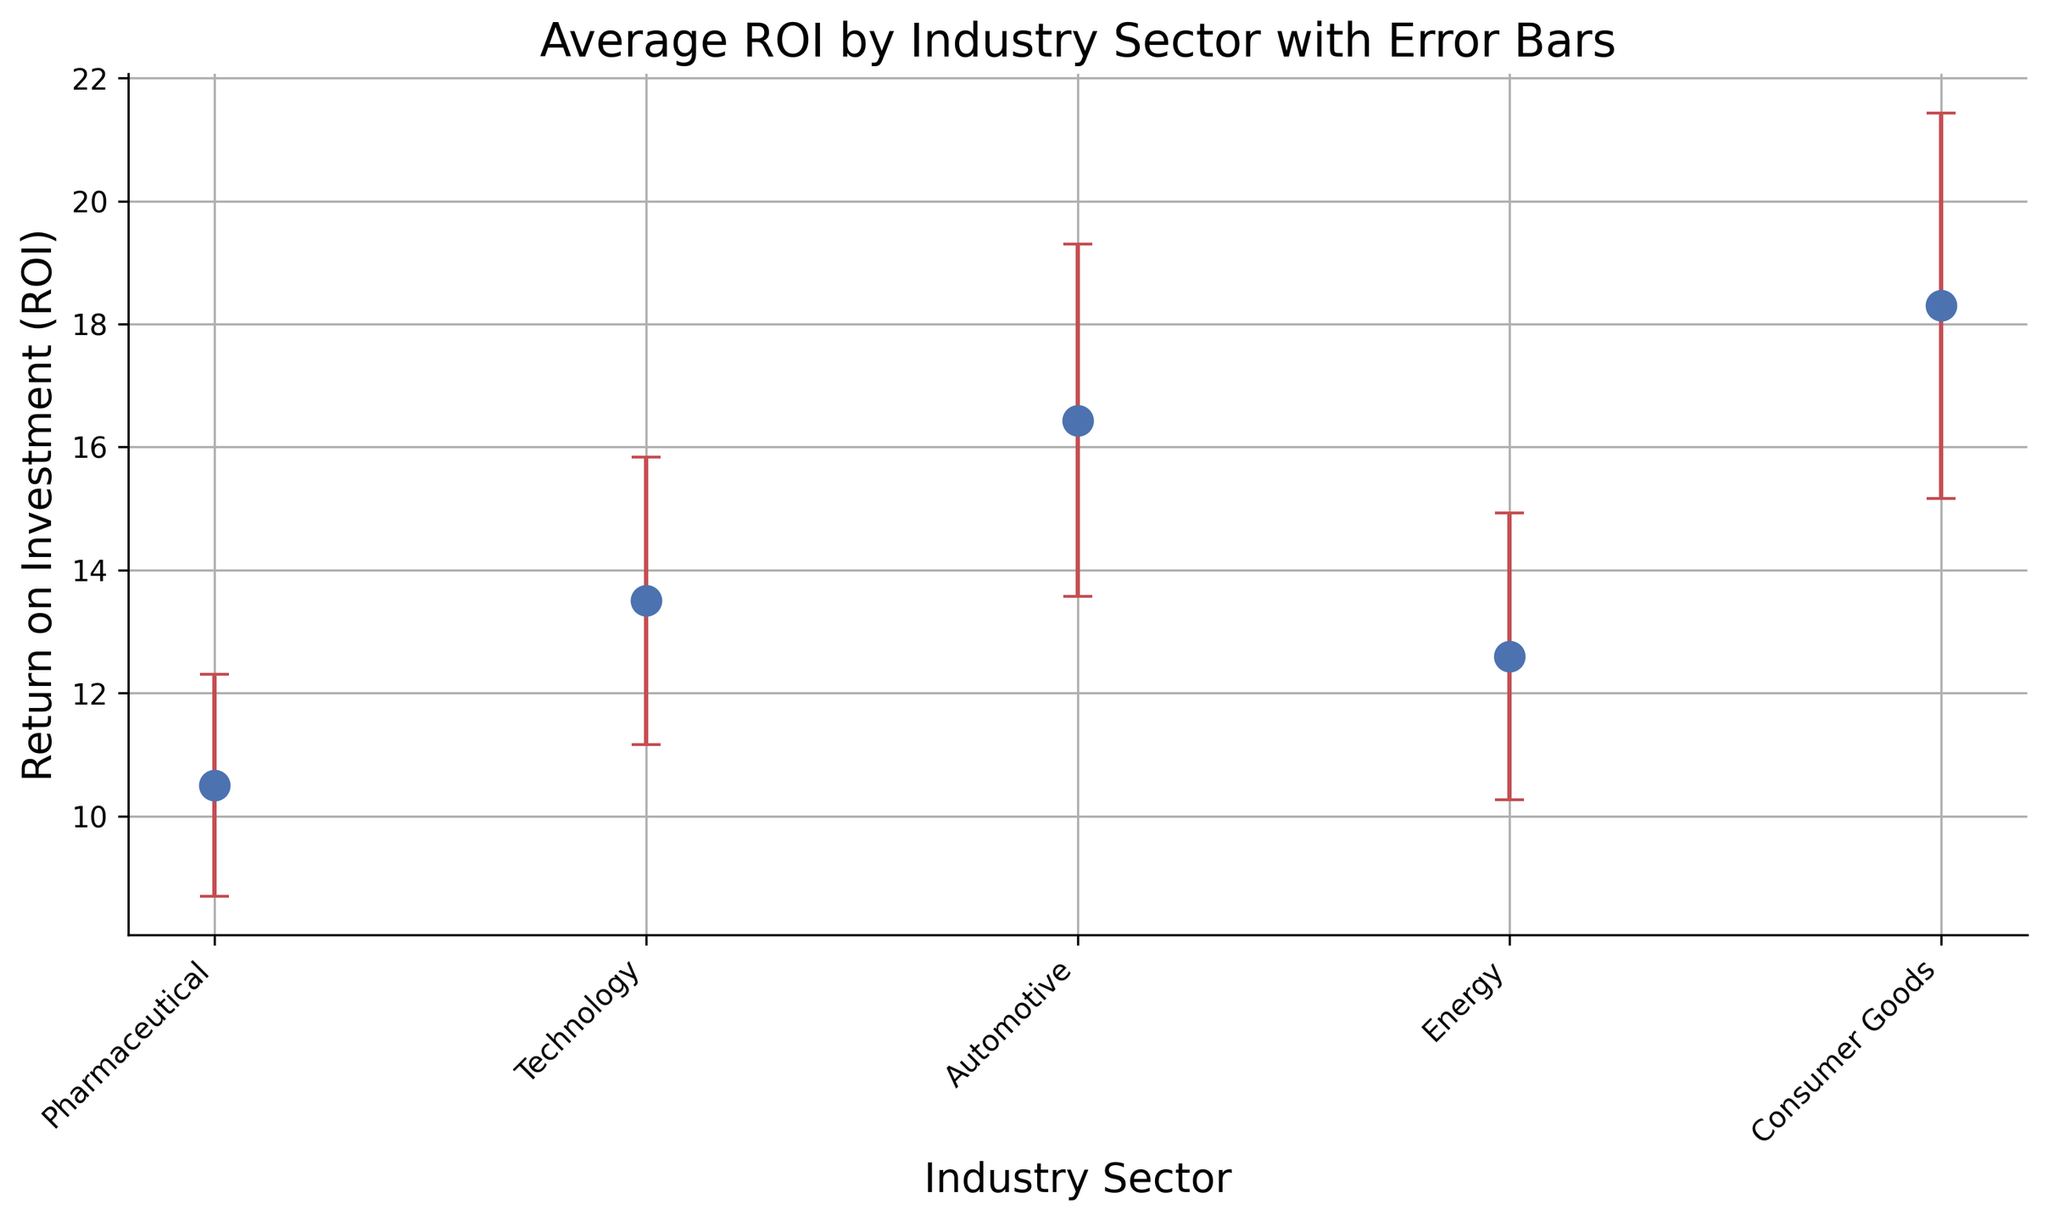Which industry sector has the highest average ROI? The highest average ROI can be determined by looking at the y-values of the markers. The Technology sector marker is the highest on the y-axis among all sectors.
Answer: Technology What is the average ROI in the Pharmaceutical sector? Locate the marker corresponding to the Pharmaceutical sector on the x-axis, then read its y-value. The Pharmaceutical sector marker aligns with the y-axis at approximately 12.6.
Answer: 12.6 Which industry sector has the largest variability in project performance? The sector with the largest error bars indicates the highest standard deviation. Technology's error bars are the tallest, indicating it has the largest performance variability.
Answer: Technology How does the average ROI of the Energy sector compare to the Consumer Goods sector? Locate the markers for both sectors on the x-axis and compare their y-values. The Energy sector has a higher y-value than the Consumer Goods sector.
Answer: Energy has a higher average ROI What is the difference in average ROI between the Technology and Automotive sectors? Find the markers for Technology and Automotive sectors on the x-axis and read their y-values. The difference is calculated as 18.3 (Technology) - 10.5 (Automotive).
Answer: 7.8 Arrange the industry sectors in descending order of their average ROI. Read and compare the y-values for each sector. The order is Technology, Energy, Consumer Goods, Pharmaceutical, and Automotive.
Answer: Technology, Energy, Consumer Goods, Pharmaceutical, Automotive Which industry sector has the closest average ROI to the Pharmaceutical sector? Compare the y-value of Pharmaceutical with other sectors. Consumer Goods’ y-value is closest to Pharmaceutical's y-value.
Answer: Consumer Goods What is the range of the ROI values for the Automotive sector? Add the error bars' length to and subtract it from the average ROI of Automotive sector. For Automotive (10.5) with a standard deviation of 1.8, the range is 10.5 - 1.8 to 10.5 + 1.8.
Answer: 8.7 to 12.3 Does any sector's ROI overlap with the range of Energy’s ROI considering their standard deviation? Calculate the range for Energy's ROI (16 - 2.9 to 16 + 2.9). Check if any other sector’s ROI range intersects with this range. The Technology sector overlaps with Energy’s ROI range.
Answer: Yes, Technology 